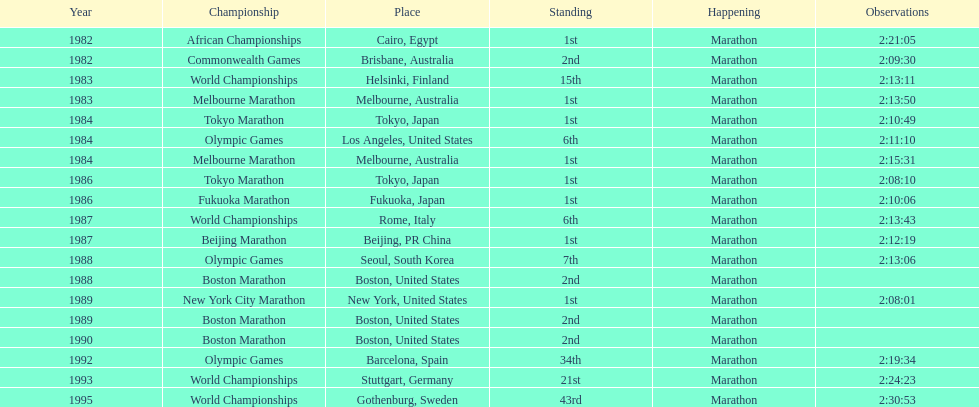Which was the only competition to occur in china? Beijing Marathon. 